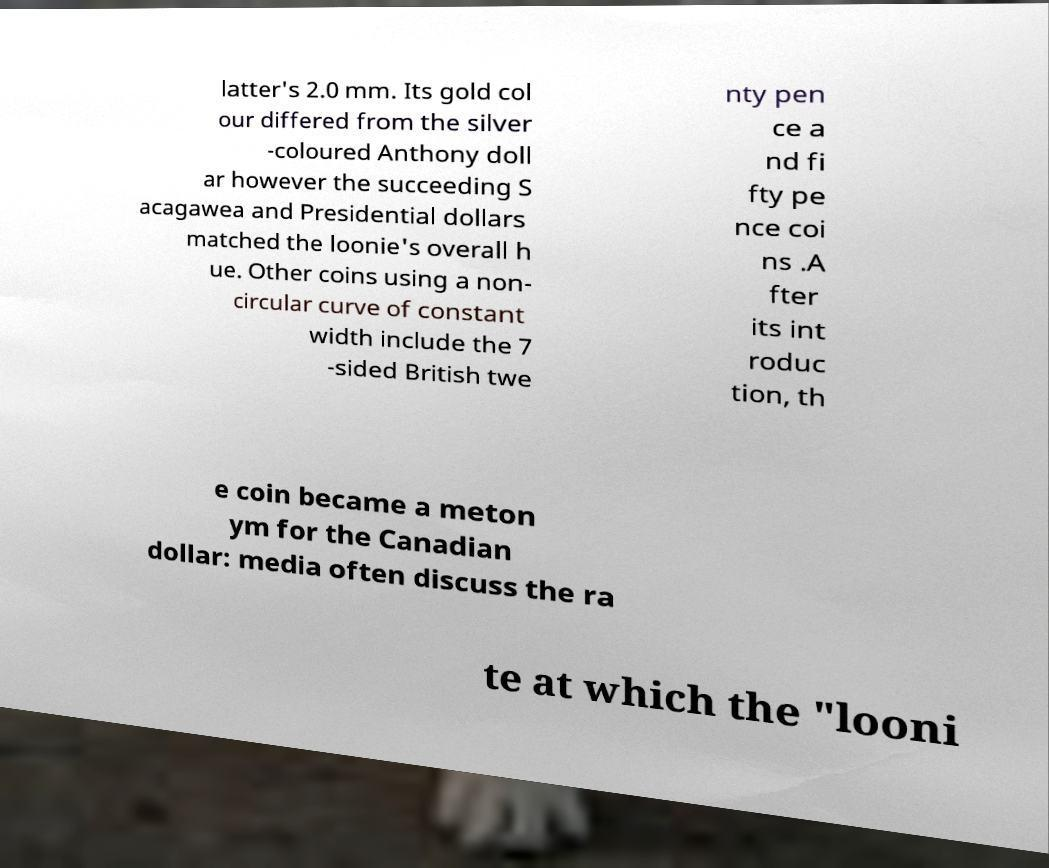I need the written content from this picture converted into text. Can you do that? latter's 2.0 mm. Its gold col our differed from the silver -coloured Anthony doll ar however the succeeding S acagawea and Presidential dollars matched the loonie's overall h ue. Other coins using a non- circular curve of constant width include the 7 -sided British twe nty pen ce a nd fi fty pe nce coi ns .A fter its int roduc tion, th e coin became a meton ym for the Canadian dollar: media often discuss the ra te at which the "looni 